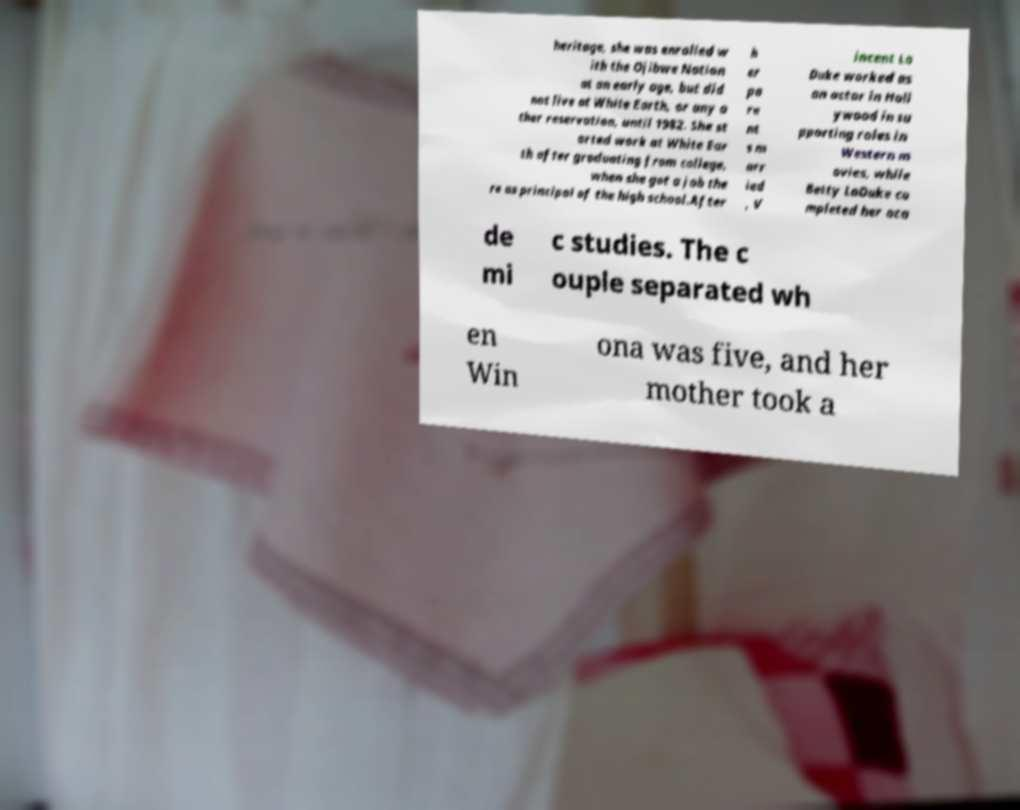Could you assist in decoding the text presented in this image and type it out clearly? heritage, she was enrolled w ith the Ojibwe Nation at an early age, but did not live at White Earth, or any o ther reservation, until 1982. She st arted work at White Ear th after graduating from college, when she got a job the re as principal of the high school.After h er pa re nt s m arr ied , V incent La Duke worked as an actor in Holl ywood in su pporting roles in Western m ovies, while Betty LaDuke co mpleted her aca de mi c studies. The c ouple separated wh en Win ona was five, and her mother took a 